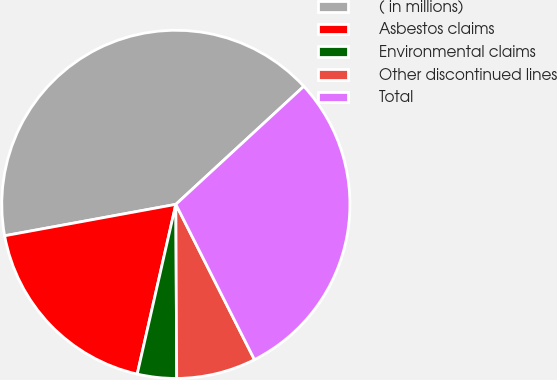Convert chart. <chart><loc_0><loc_0><loc_500><loc_500><pie_chart><fcel>( in millions)<fcel>Asbestos claims<fcel>Environmental claims<fcel>Other discontinued lines<fcel>Total<nl><fcel>41.03%<fcel>18.55%<fcel>3.64%<fcel>7.38%<fcel>29.4%<nl></chart> 